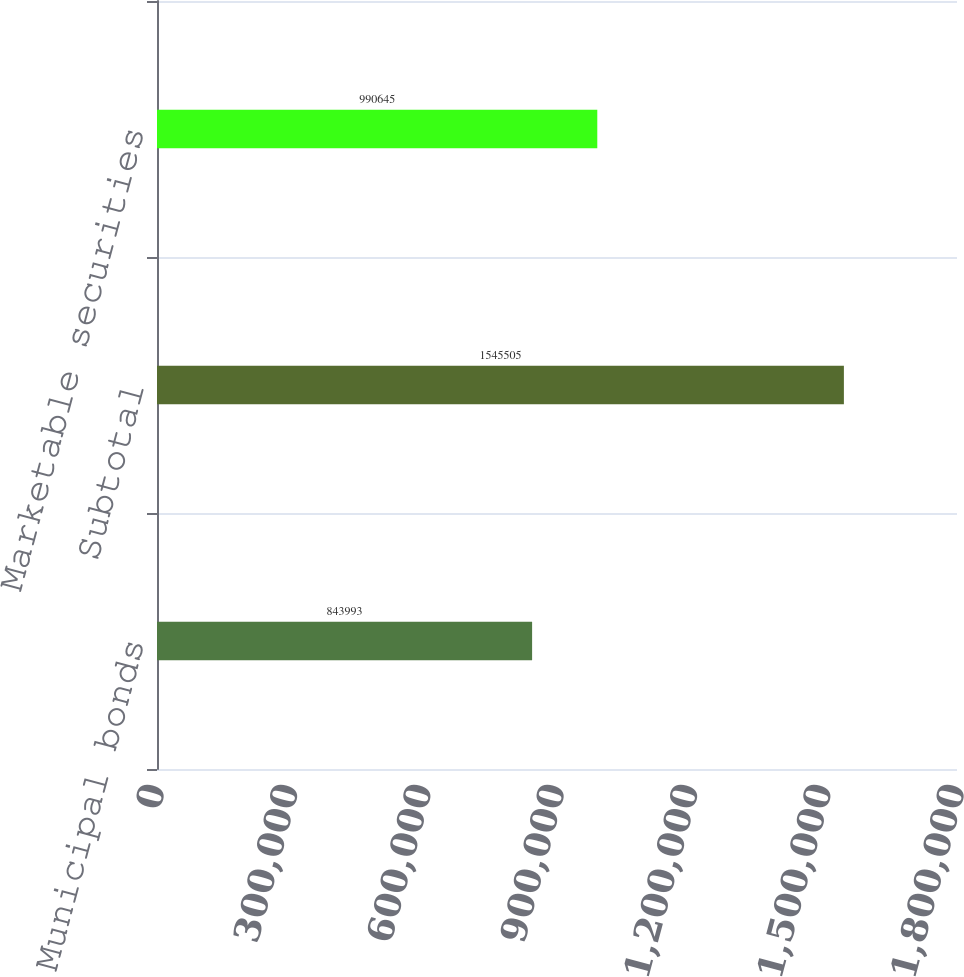Convert chart to OTSL. <chart><loc_0><loc_0><loc_500><loc_500><bar_chart><fcel>Municipal bonds<fcel>Subtotal<fcel>Marketable securities<nl><fcel>843993<fcel>1.5455e+06<fcel>990645<nl></chart> 